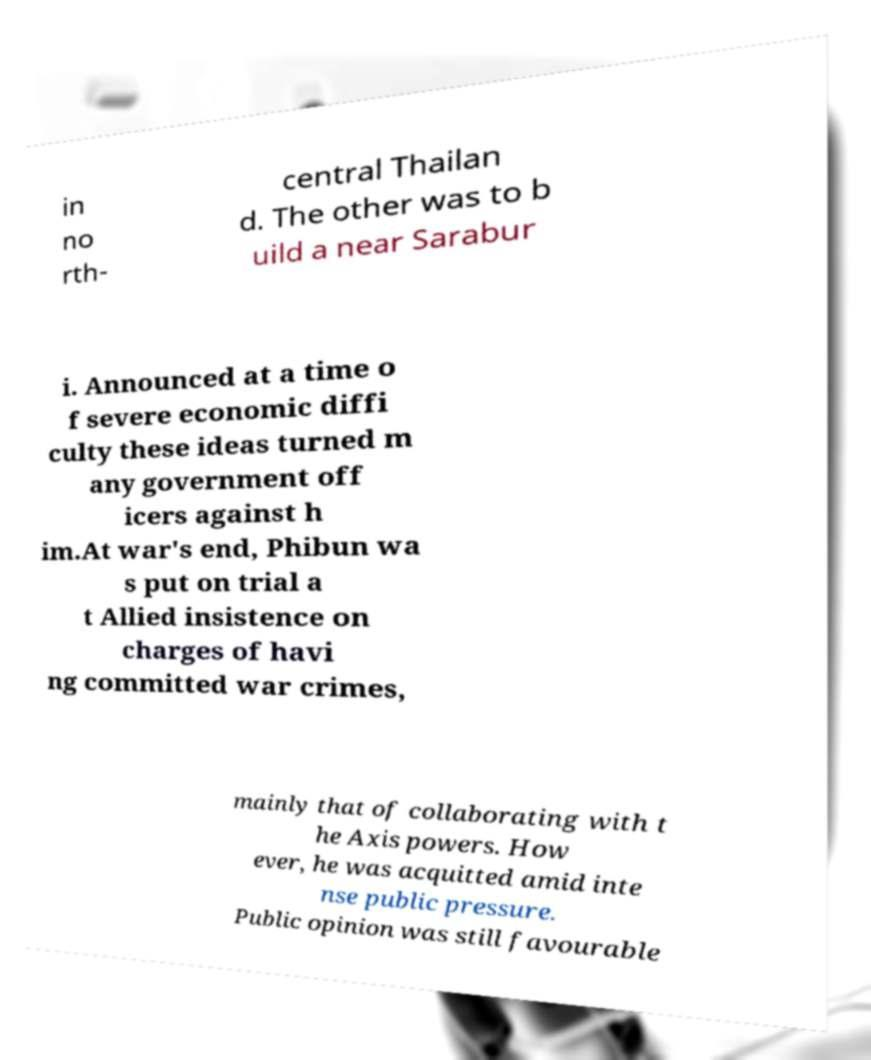Could you extract and type out the text from this image? in no rth- central Thailan d. The other was to b uild a near Sarabur i. Announced at a time o f severe economic diffi culty these ideas turned m any government off icers against h im.At war's end, Phibun wa s put on trial a t Allied insistence on charges of havi ng committed war crimes, mainly that of collaborating with t he Axis powers. How ever, he was acquitted amid inte nse public pressure. Public opinion was still favourable 